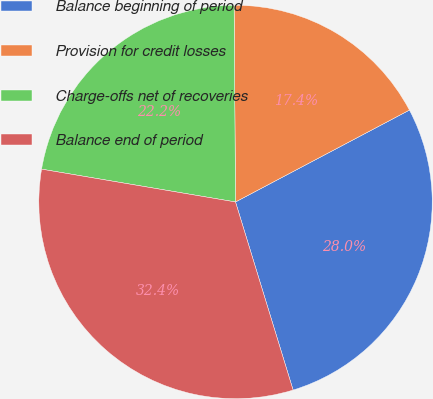Convert chart. <chart><loc_0><loc_0><loc_500><loc_500><pie_chart><fcel>Balance beginning of period<fcel>Provision for credit losses<fcel>Charge-offs net of recoveries<fcel>Balance end of period<nl><fcel>28.01%<fcel>17.38%<fcel>22.22%<fcel>32.4%<nl></chart> 